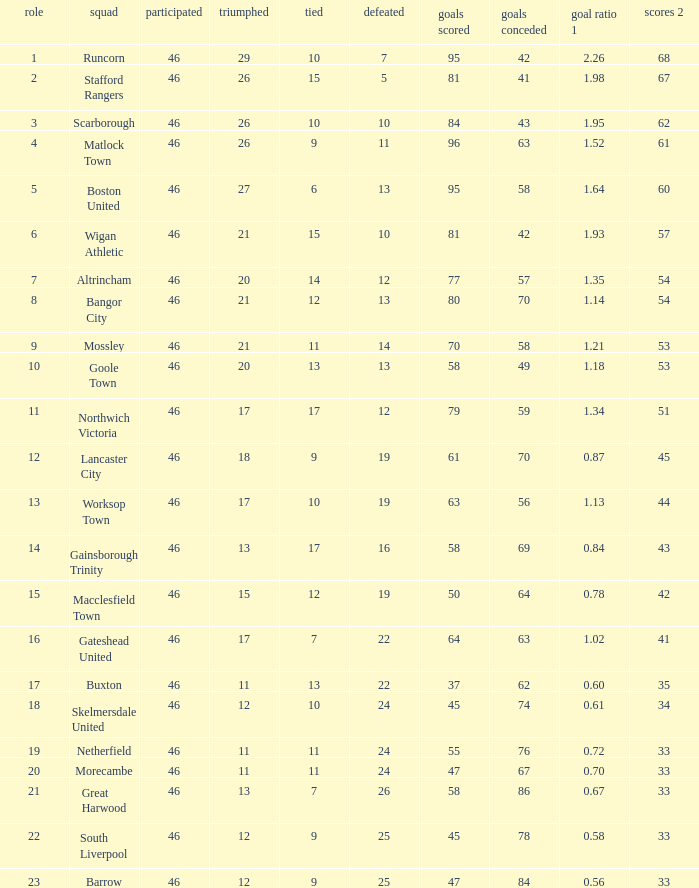List all losses with average goals of 1.21. 14.0. Can you parse all the data within this table? {'header': ['role', 'squad', 'participated', 'triumphed', 'tied', 'defeated', 'goals scored', 'goals conceded', 'goal ratio 1', 'scores 2'], 'rows': [['1', 'Runcorn', '46', '29', '10', '7', '95', '42', '2.26', '68'], ['2', 'Stafford Rangers', '46', '26', '15', '5', '81', '41', '1.98', '67'], ['3', 'Scarborough', '46', '26', '10', '10', '84', '43', '1.95', '62'], ['4', 'Matlock Town', '46', '26', '9', '11', '96', '63', '1.52', '61'], ['5', 'Boston United', '46', '27', '6', '13', '95', '58', '1.64', '60'], ['6', 'Wigan Athletic', '46', '21', '15', '10', '81', '42', '1.93', '57'], ['7', 'Altrincham', '46', '20', '14', '12', '77', '57', '1.35', '54'], ['8', 'Bangor City', '46', '21', '12', '13', '80', '70', '1.14', '54'], ['9', 'Mossley', '46', '21', '11', '14', '70', '58', '1.21', '53'], ['10', 'Goole Town', '46', '20', '13', '13', '58', '49', '1.18', '53'], ['11', 'Northwich Victoria', '46', '17', '17', '12', '79', '59', '1.34', '51'], ['12', 'Lancaster City', '46', '18', '9', '19', '61', '70', '0.87', '45'], ['13', 'Worksop Town', '46', '17', '10', '19', '63', '56', '1.13', '44'], ['14', 'Gainsborough Trinity', '46', '13', '17', '16', '58', '69', '0.84', '43'], ['15', 'Macclesfield Town', '46', '15', '12', '19', '50', '64', '0.78', '42'], ['16', 'Gateshead United', '46', '17', '7', '22', '64', '63', '1.02', '41'], ['17', 'Buxton', '46', '11', '13', '22', '37', '62', '0.60', '35'], ['18', 'Skelmersdale United', '46', '12', '10', '24', '45', '74', '0.61', '34'], ['19', 'Netherfield', '46', '11', '11', '24', '55', '76', '0.72', '33'], ['20', 'Morecambe', '46', '11', '11', '24', '47', '67', '0.70', '33'], ['21', 'Great Harwood', '46', '13', '7', '26', '58', '86', '0.67', '33'], ['22', 'South Liverpool', '46', '12', '9', '25', '45', '78', '0.58', '33'], ['23', 'Barrow', '46', '12', '9', '25', '47', '84', '0.56', '33']]} 